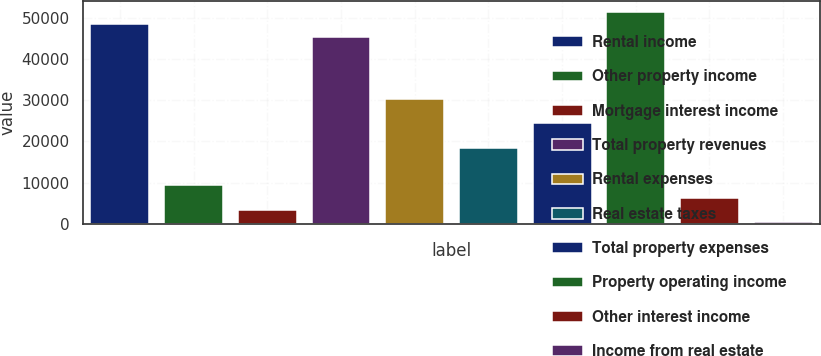<chart> <loc_0><loc_0><loc_500><loc_500><bar_chart><fcel>Rental income<fcel>Other property income<fcel>Mortgage interest income<fcel>Total property revenues<fcel>Rental expenses<fcel>Real estate taxes<fcel>Total property expenses<fcel>Property operating income<fcel>Other interest income<fcel>Income from real estate<nl><fcel>48556.8<fcel>9338.4<fcel>3304.8<fcel>45540<fcel>30456<fcel>18388.8<fcel>24422.4<fcel>51573.6<fcel>6321.6<fcel>288<nl></chart> 